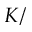<formula> <loc_0><loc_0><loc_500><loc_500>K /</formula> 